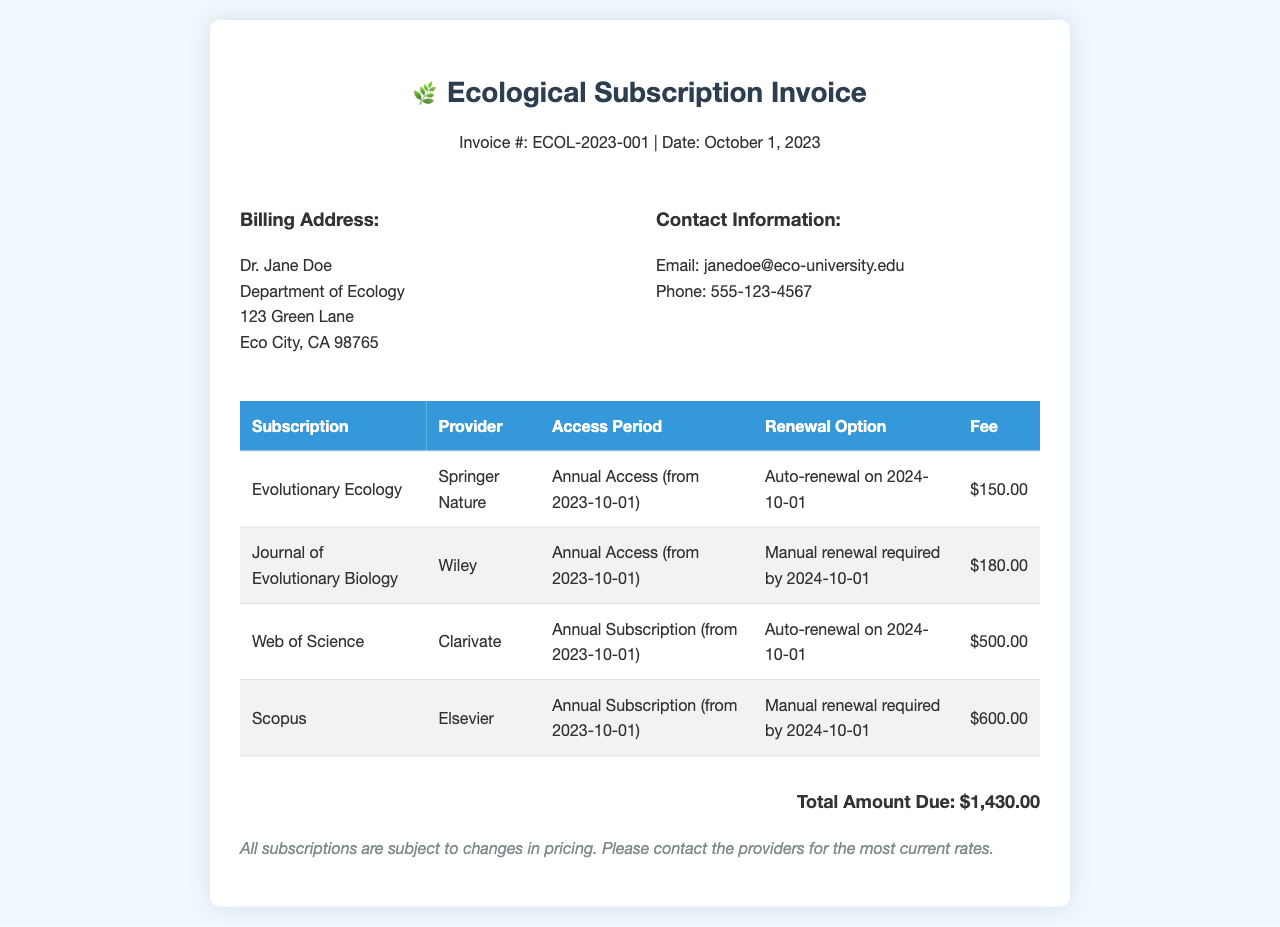What is the invoice number? The invoice number is listed at the top of the document as ECOL-2023-001.
Answer: ECOL-2023-001 What is the date of the invoice? The date of the invoice is mentioned right below the invoice number as October 1, 2023.
Answer: October 1, 2023 How many subscriptions are listed in the invoice? The invoice lists four subscriptions under the subscription details table.
Answer: 4 What is the total amount due? The total amount due is provided at the bottom of the invoice as $1,430.00.
Answer: $1,430.00 Which subscription has a manual renewal requirement? The subscriptions with manual renewal are Journal of Evolutionary Biology and Scopus, as indicated in the renewal option column.
Answer: Journal of Evolutionary Biology, Scopus When does the auto-renewal for Evolutionary Ecology occur? The auto-renewal date for Evolutionary Ecology is specified in the renewal option as 2024-10-01.
Answer: 2024-10-01 Who is the billing address for the invoice? The billing address belongs to Dr. Jane Doe, as shown in the billing information section of the document.
Answer: Dr. Jane Doe What is the provider for Web of Science? The provider for Web of Science is mentioned in the table as Clarivate.
Answer: Clarivate 